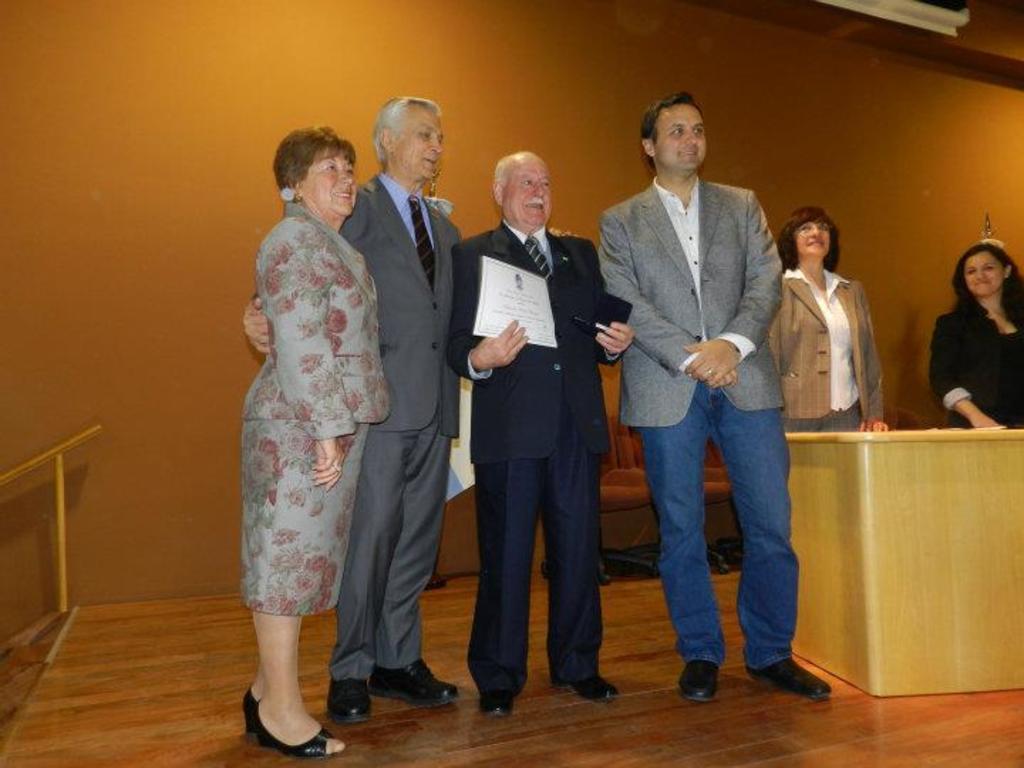In one or two sentences, can you explain what this image depicts? In front of the image on the stage there are three men and one lady. They are standing. There is a man holding a certificate and some other object in his hand. On the right side of the image there is a table. Behind the table there are two ladies standing. Behind them there are chairs. On the left side of the image there is railing.  